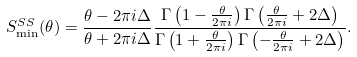<formula> <loc_0><loc_0><loc_500><loc_500>S ^ { S S } _ { \min } ( \theta ) = \frac { \theta - 2 \pi i \Delta } { \theta + 2 \pi i \Delta } \frac { \Gamma \left ( 1 - \frac { \theta } { 2 \pi i } \right ) \Gamma \left ( \frac { \theta } { 2 \pi i } + 2 \Delta \right ) } { \Gamma \left ( 1 + \frac { \theta } { 2 \pi i } \right ) \Gamma \left ( - \frac { \theta } { 2 \pi i } + 2 \Delta \right ) } .</formula> 